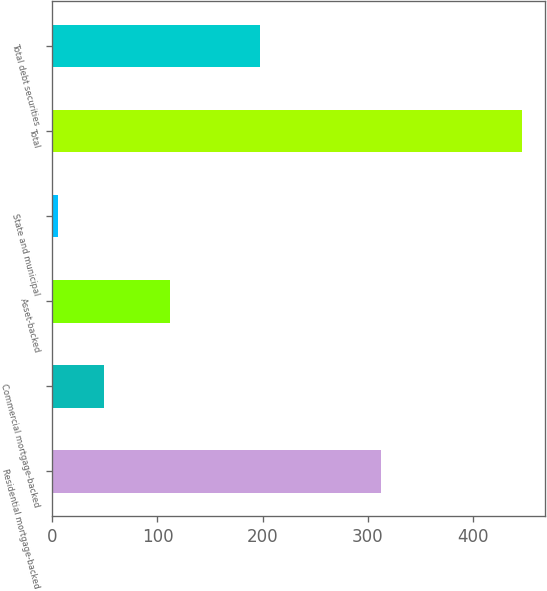Convert chart to OTSL. <chart><loc_0><loc_0><loc_500><loc_500><bar_chart><fcel>Residential mortgage-backed<fcel>Commercial mortgage-backed<fcel>Asset-backed<fcel>State and municipal<fcel>Total<fcel>Total debt securities<nl><fcel>313<fcel>49.2<fcel>112<fcel>5<fcel>447<fcel>198<nl></chart> 